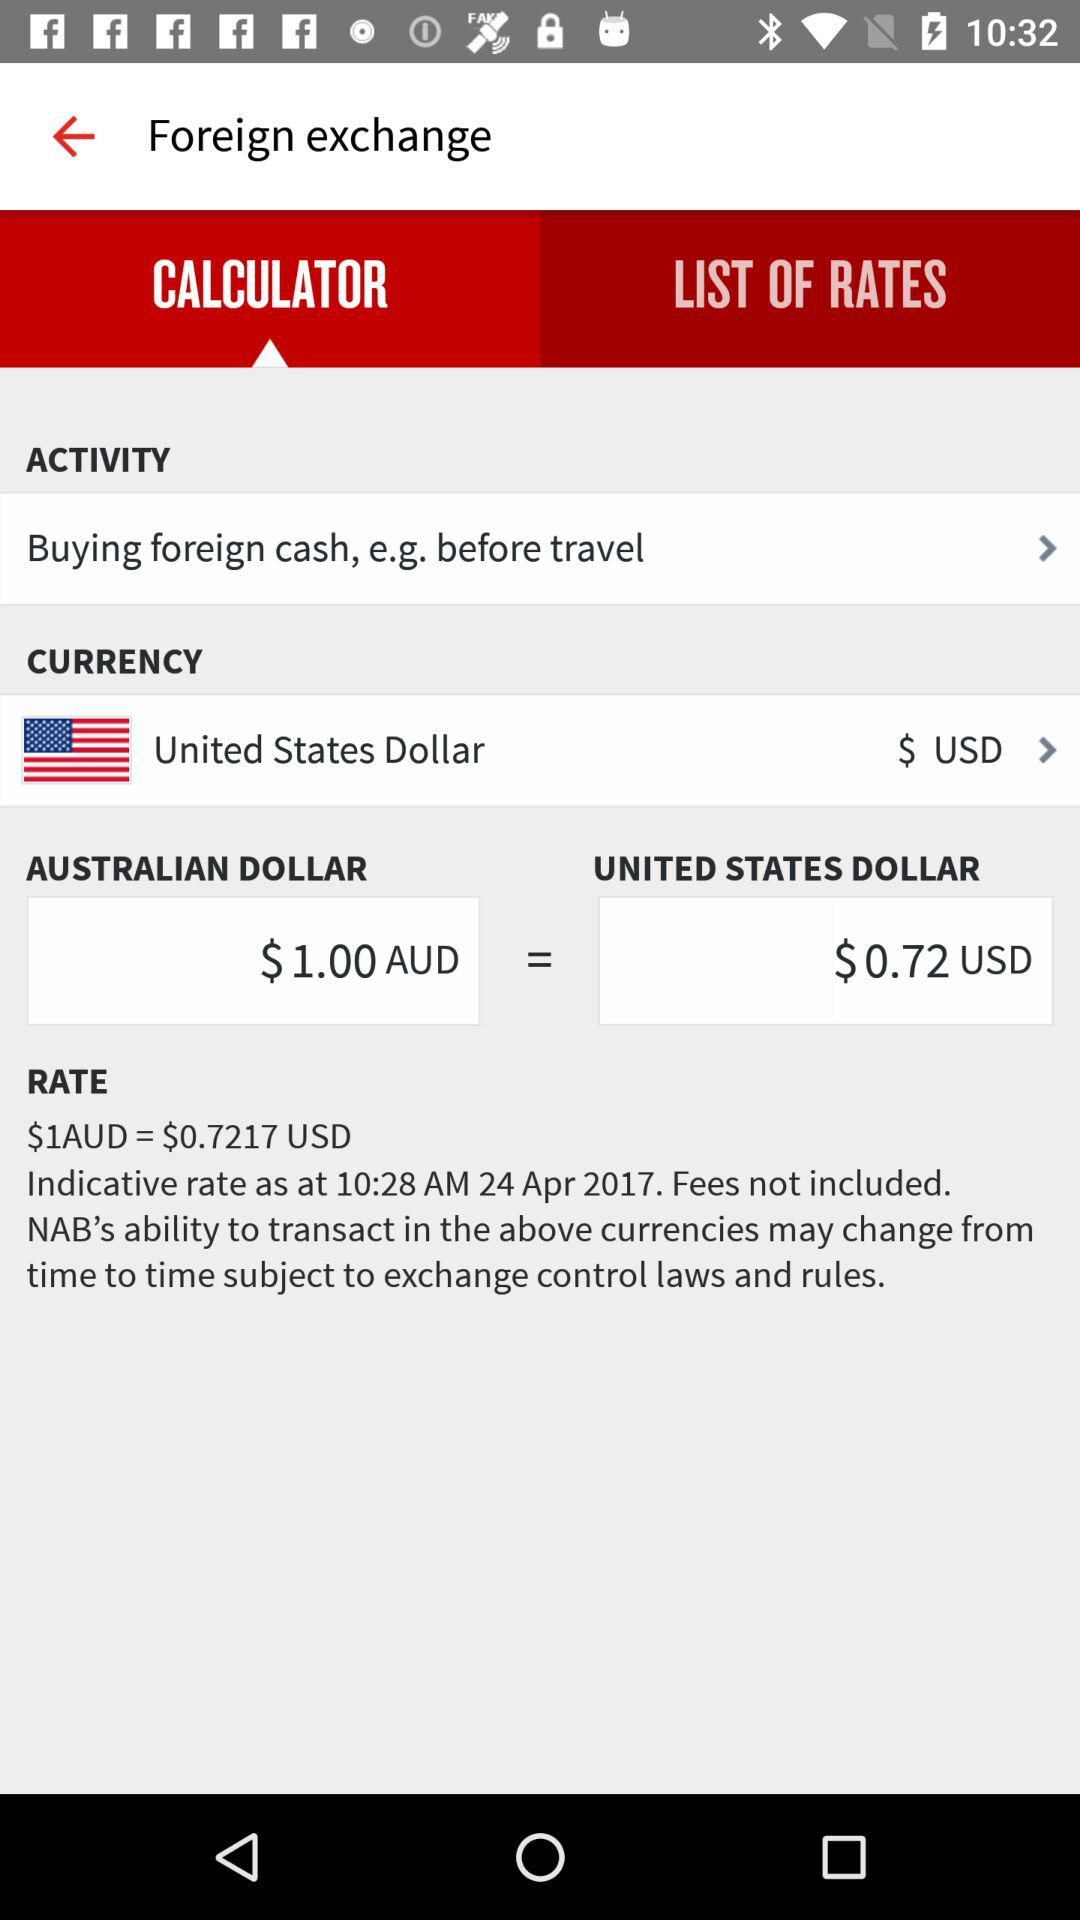Which country's currency was selected? The country whose currency was selected is the United States of America. 